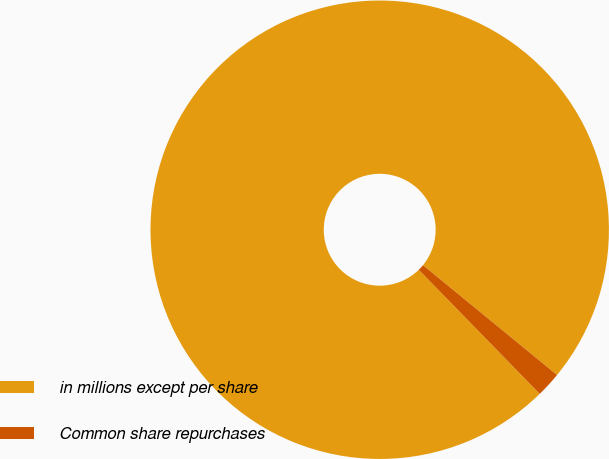Convert chart. <chart><loc_0><loc_0><loc_500><loc_500><pie_chart><fcel>in millions except per share<fcel>Common share repurchases<nl><fcel>98.22%<fcel>1.78%<nl></chart> 